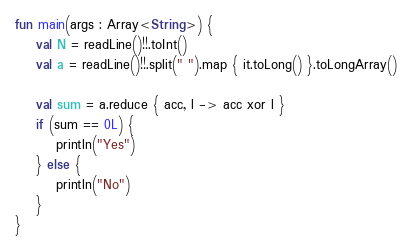Convert code to text. <code><loc_0><loc_0><loc_500><loc_500><_Kotlin_>fun main(args : Array<String>) {
    val N = readLine()!!.toInt()
    val a = readLine()!!.split(" ").map { it.toLong() }.toLongArray()

    val sum = a.reduce { acc, l -> acc xor l }
    if (sum == 0L) {
        println("Yes")
    } else {
        println("No")
    }
}</code> 